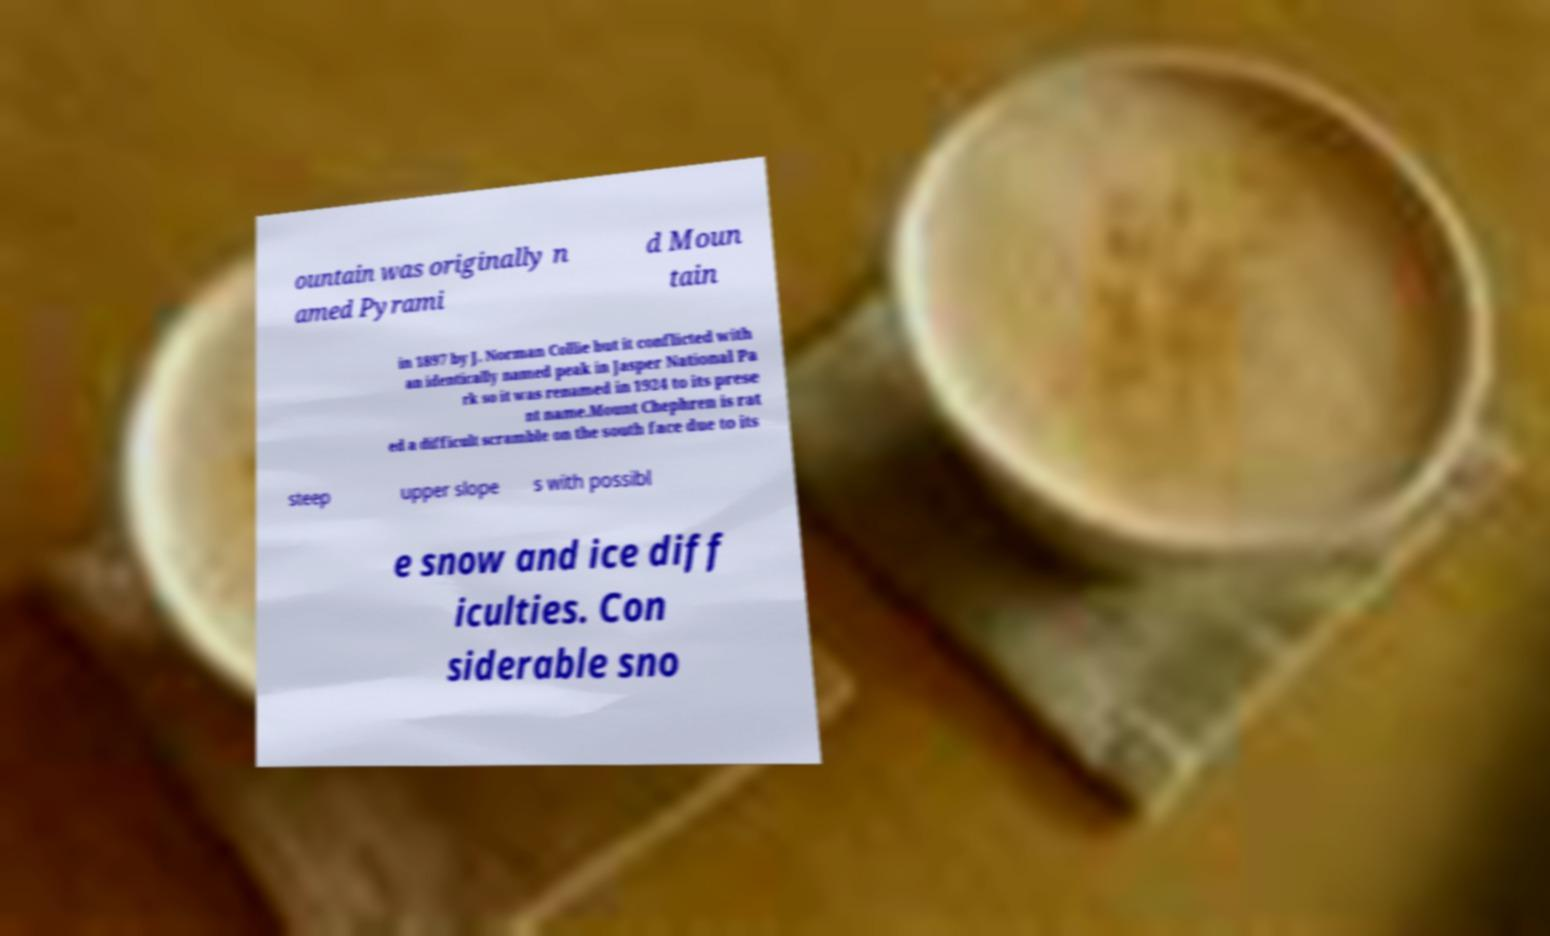Could you assist in decoding the text presented in this image and type it out clearly? ountain was originally n amed Pyrami d Moun tain in 1897 by J. Norman Collie but it conflicted with an identically named peak in Jasper National Pa rk so it was renamed in 1924 to its prese nt name.Mount Chephren is rat ed a difficult scramble on the south face due to its steep upper slope s with possibl e snow and ice diff iculties. Con siderable sno 